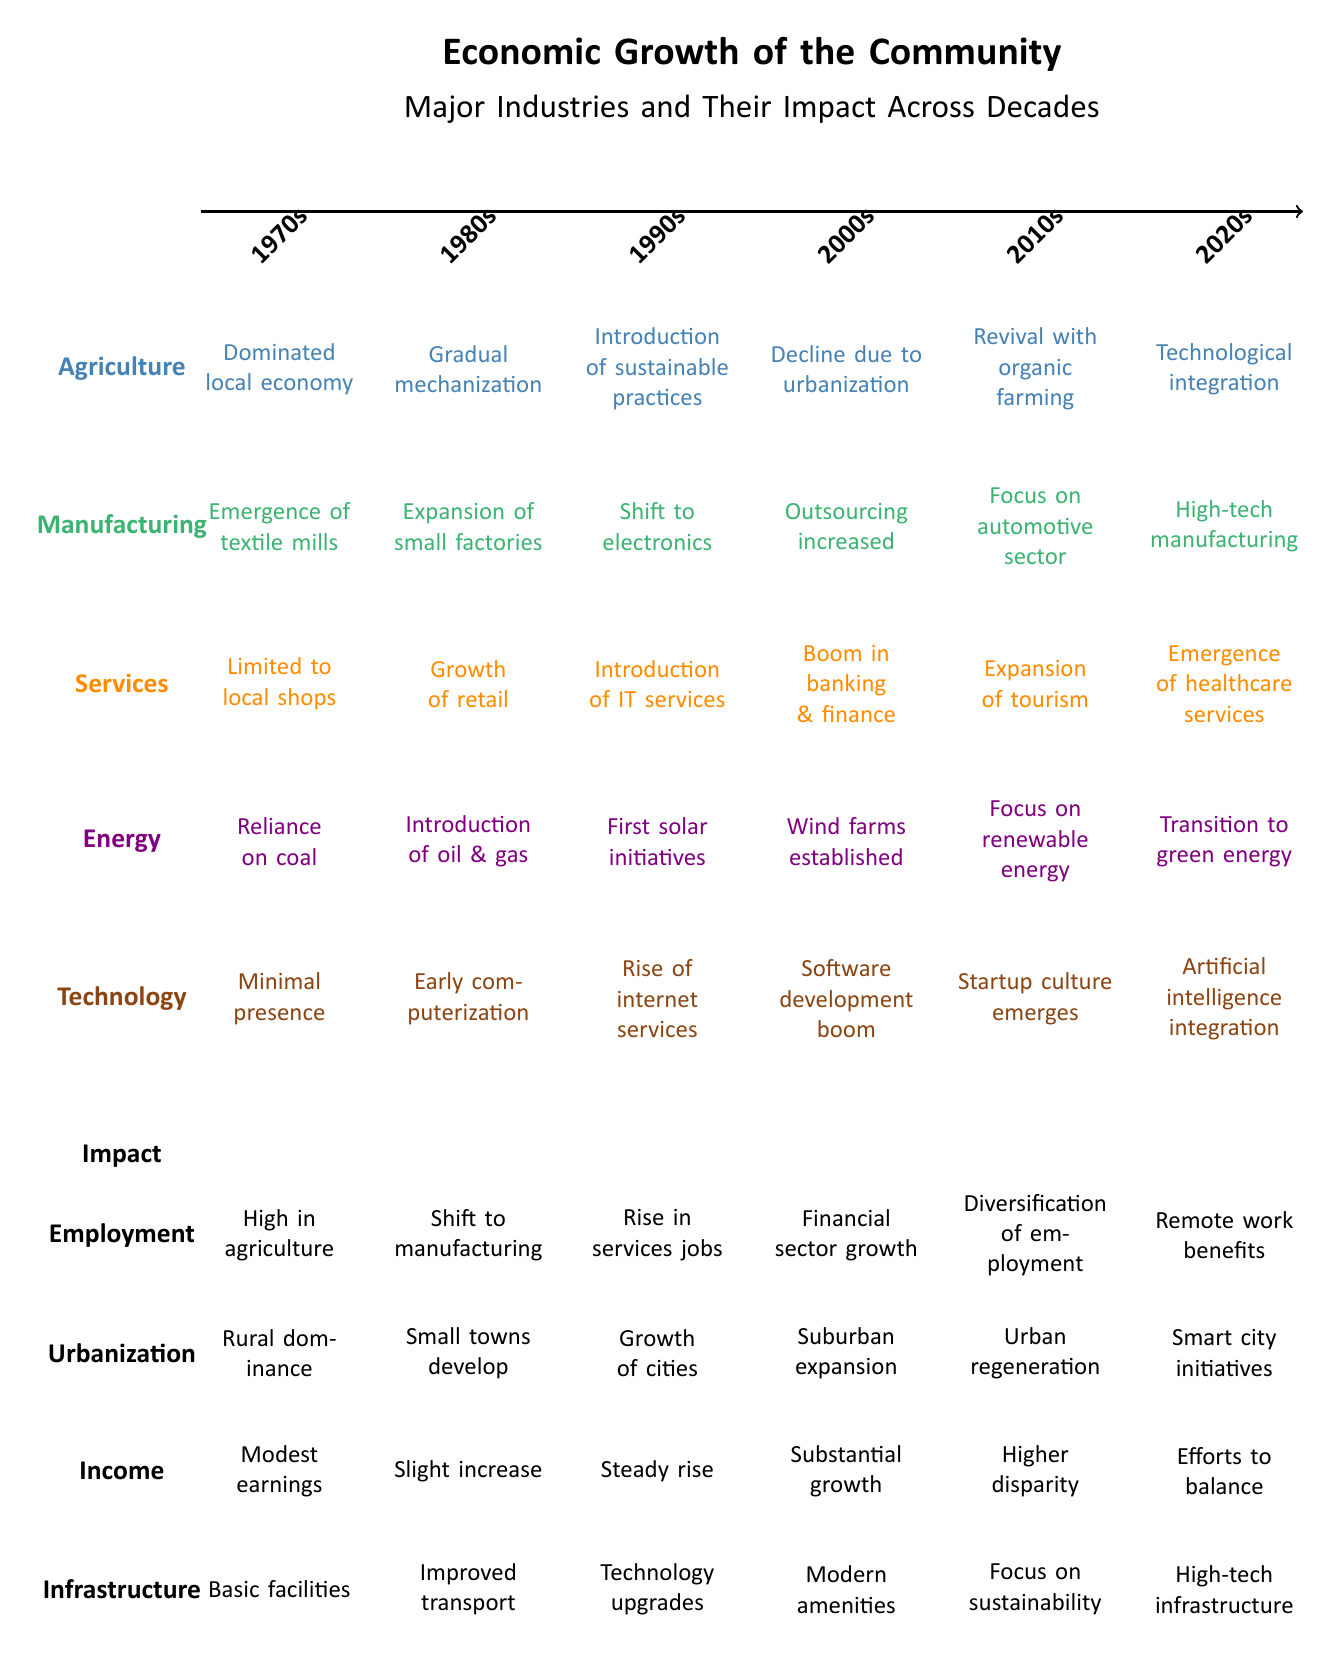What was the dominant economic sector in the 1970s? The diagram indicates that Agriculture dominated the local economy in the 1970s as noted at the top left corner under the Agriculture section.
Answer: Agriculture Which industry saw a shift towards electronics in the 1990s? The Manufacturing industry is noted to have shifted to electronics in the 1990s, as mentioned directly below the 1990s year marker.
Answer: Manufacturing In which decade did the services sector experience a boom in banking and finance? The boom in banking and finance occurred in the 2000s, as described in the Services section directly under the 2000s label.
Answer: 2000s How did the technology sector evolve from the 1980s to the 2020s? The technology sector progressed from minimal presence in the 1970s to artificial intelligence integration in the 2020s, highlighting significant advancements over the decades as outlined in the Technology section.
Answer: From minimal presence to artificial intelligence integration What notable change did Agriculture undergo in the 2010s according to the diagram? In the 2010s, Agriculture experienced a revival with organic farming as indicated in the Agriculture section under the respective decade marker.
Answer: Revival with organic farming Which decade marked the beginning of the introduction of IT services? The introduction of IT services occurred in the 1990s, as specified in the Services section directly beneath the 1990s label.
Answer: 1990s What impact did the transition to green energy have on the community depicted in the diagram? The transition to green energy is part of a broader focus on renewable energy that likely led to improvements in energy sustainability, as shown under the Energy sector in the 2020s.
Answer: Transition to green energy How did urbanization evolve from the 1970s to the 2020s in terms of demographic patterns? Urbanization evolved from rural dominance in the 1970s to smart city initiatives in the 2020s, indicating a significant transformation in the demographic landscape as displayed in the Urbanization impact section.
Answer: From rural dominance to smart city initiatives 